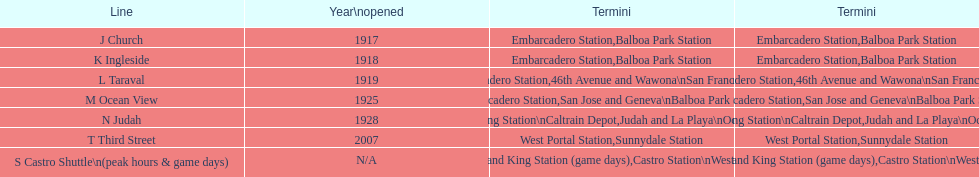During game days, which line would you like to utilize? S Castro Shuttle. 